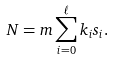Convert formula to latex. <formula><loc_0><loc_0><loc_500><loc_500>N = m \sum _ { i = 0 } ^ { \ell } k _ { i } s _ { i } .</formula> 